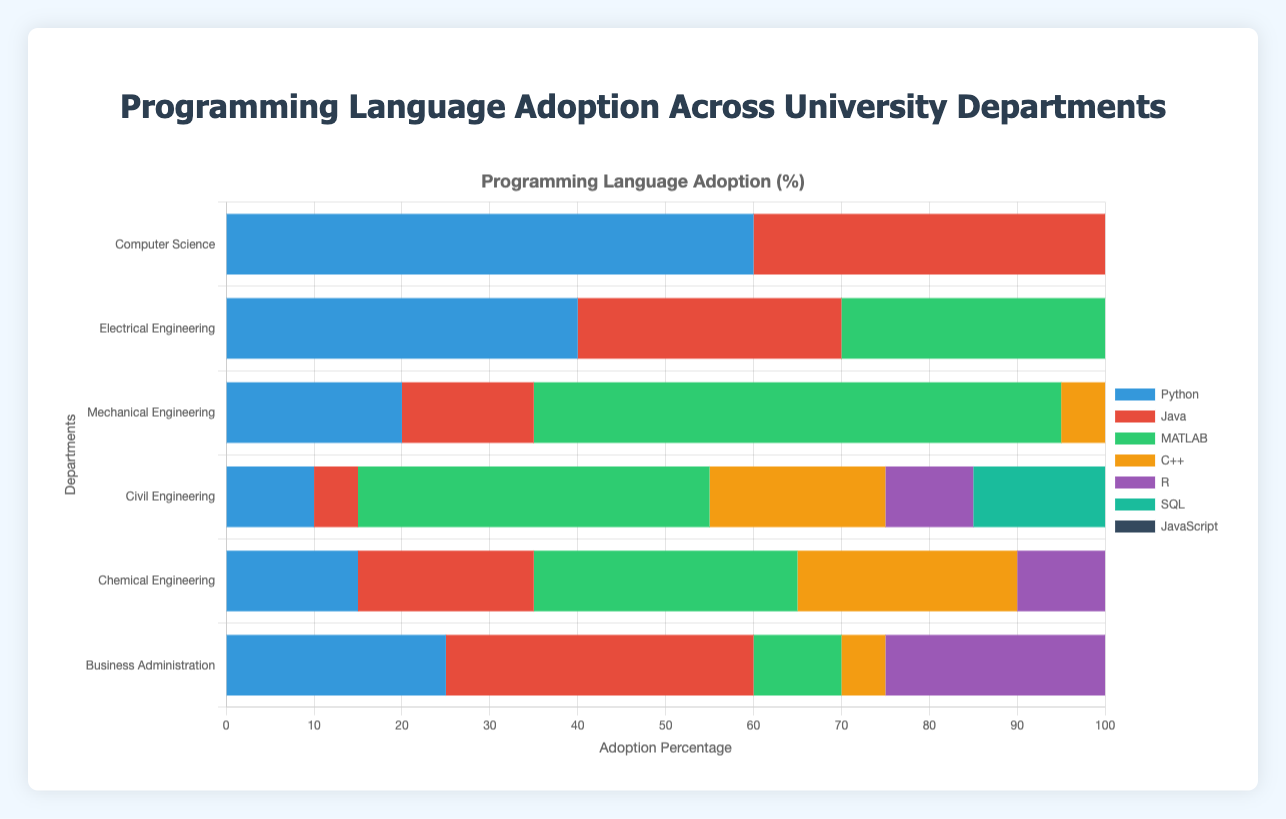Which department shows the highest adoption of MATLAB? To find the department with the highest adoption of MATLAB, look for the longest section of the bar colored for MATLAB (which is the visual indicator you need). From the figure, Mechanical Engineering has the longest MATLAB section.
Answer: Mechanical Engineering What is the combined adoption percentage of Python and Java in the Electrical Engineering department? First, find the horizontal length of the bars corresponding to Python and Java within the Electrical Engineering row. For Python, it is 40% and for Java, it is 30%. Adding these gives 40 + 30 = 70.
Answer: 70% Which programming language is most adopted by the Business Administration department? Look at the sections of the stacked bar under Business Administration. The tallest one corresponds to SQL. This means SQL has the highest adoption in this department.
Answer: SQL Compare the adoption of JavaScript and R in the Computer Science department. Which language has a higher adoption? Within the Computer Science row, compare the lengths of the JavaScript and R bars. JavaScript is at 45%, whereas R is at 25%. Thus, JavaScript has a higher adoption.
Answer: JavaScript In which department is the adoption of C++ equal to the adoption of MATLAB in the Chemical Engineering department? Look at the bar for MATLAB under Chemical Engineering, which is 30%. Find the department in the row of C++ where the section is also 30%. Both Mechanical Engineering and Chemical Engineering have 30% adoption for C++.
Answer: Mechanical Engineering What is the visual color representing Python, and which department has the highest adoption for it? Python is represented by a specific color (you find the color visually in the chart). By observing the chart, you see the length of the Python bar for each department. The longest bar is under Computer Science.
Answer: Python is blue (assuming the first color in the color set) and highest in Computer Science Calculate the difference in adoption percentages of SQL between Mechanical Engineering and Electrical Engineering departments. SQL adoption is 25% in Mechanical Engineering and 35% in Electrical Engineering. The difference is 35 - 25 = 10.
Answer: 10% What is the average adoption percentage of JavaScript across all departments? Sum up the adoption percentages for JavaScript across all departments: (45 + 25 + 15 + 10 + 10 + 30) = 135. There are 6 departments, so the average is 135 / 6 = 22.5%.
Answer: 22.5% Which department has the least variation in the adoption of the programming languages? Look for the department where the bar sections seem most uniform in length (this suggests minimal variation). Civil Engineering appears to have the most uniform adoption across all languages.
Answer: Civil Engineering How does the adoption of Python in Business Administration compare to its adoption in Mechanical Engineering? The Python adoption is 25% in Business Administration and 20% in Mechanical Engineering. Thus, Business Administration has a higher adoption of Python.
Answer: Business Administration 